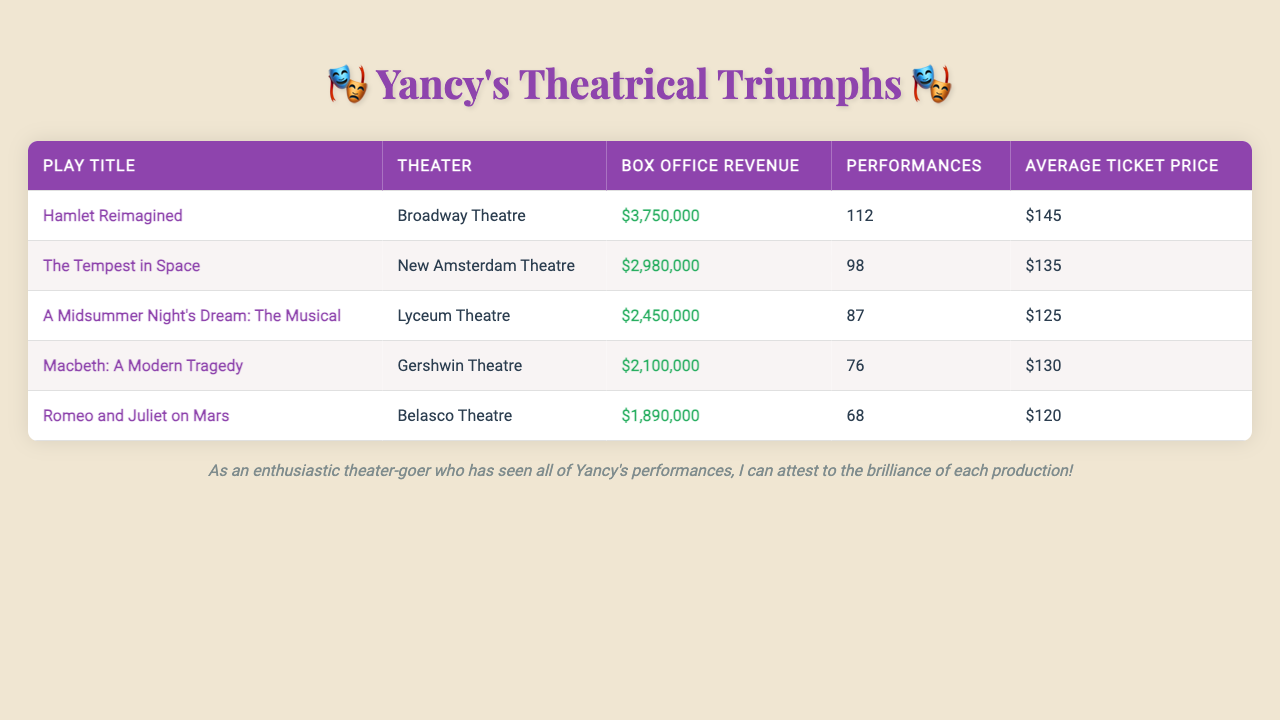What is the box office revenue for "Hamlet Reimagined"? The table shows that the box office revenue for "Hamlet Reimagined" is listed under the relevant column, which states "$3,750,000".
Answer: $3,750,000 How many performances did "The Tempest in Space" have? The table indicates that "The Tempest in Space" had a total of 98 performances listed in the corresponding column.
Answer: 98 What is the average ticket price for "Macbeth: A Modern Tragedy"? The average ticket price for "Macbeth: A Modern Tragedy" can be found in the table, which states it is "$130".
Answer: $130 Which play had the highest box office revenue? By comparing the box office revenues in the table, it is clear that "Hamlet Reimagined" has the highest revenue at "$3,750,000".
Answer: Hamlet Reimagined What is the average box office revenue for Yancy's top 5 plays? To find the average, sum up all the box office revenues ($3,750,000 + $2,980,000 + $2,450,000 + $2,100,000 + $1,890,000 = $13,170,000), then divide by the number of plays (5): $13,170,000 / 5 = $2,634,000.
Answer: $2,634,000 Does "Romeo and Juliet on Mars" have a box office revenue greater than $2 million? "Romeo and Juliet on Mars" has a box office revenue of "$1,890,000", which is less than $2 million. Therefore, the statement is false.
Answer: No What is the total number of performances across all five plays? To calculate the total, sum the performances from each play (112 + 98 + 87 + 76 + 68 = 441). The total number of performances across all five plays is 441.
Answer: 441 Which play had the lowest average ticket price? The table reveals that "Romeo and Juliet on Mars" had the lowest average ticket price listed at "$120".
Answer: Romeo and Juliet on Mars Is the average ticket price higher for "A Midsummer Night's Dream: The Musical" than for "Hamlet Reimagined"? The average ticket price for "A Midsummer Night's Dream: The Musical" is "$125" and for "Hamlet Reimagined" is "$145". Since $125 is less than $145, the statement is false.
Answer: No What is the revenue difference between "Hamlet Reimagined" and "Romeo and Juliet on Mars"? The revenue for "Hamlet Reimagined" is $3,750,000 and for "Romeo and Juliet on Mars" it is $1,890,000. The difference is $3,750,000 - $1,890,000 = $1,860,000.
Answer: $1,860,000 